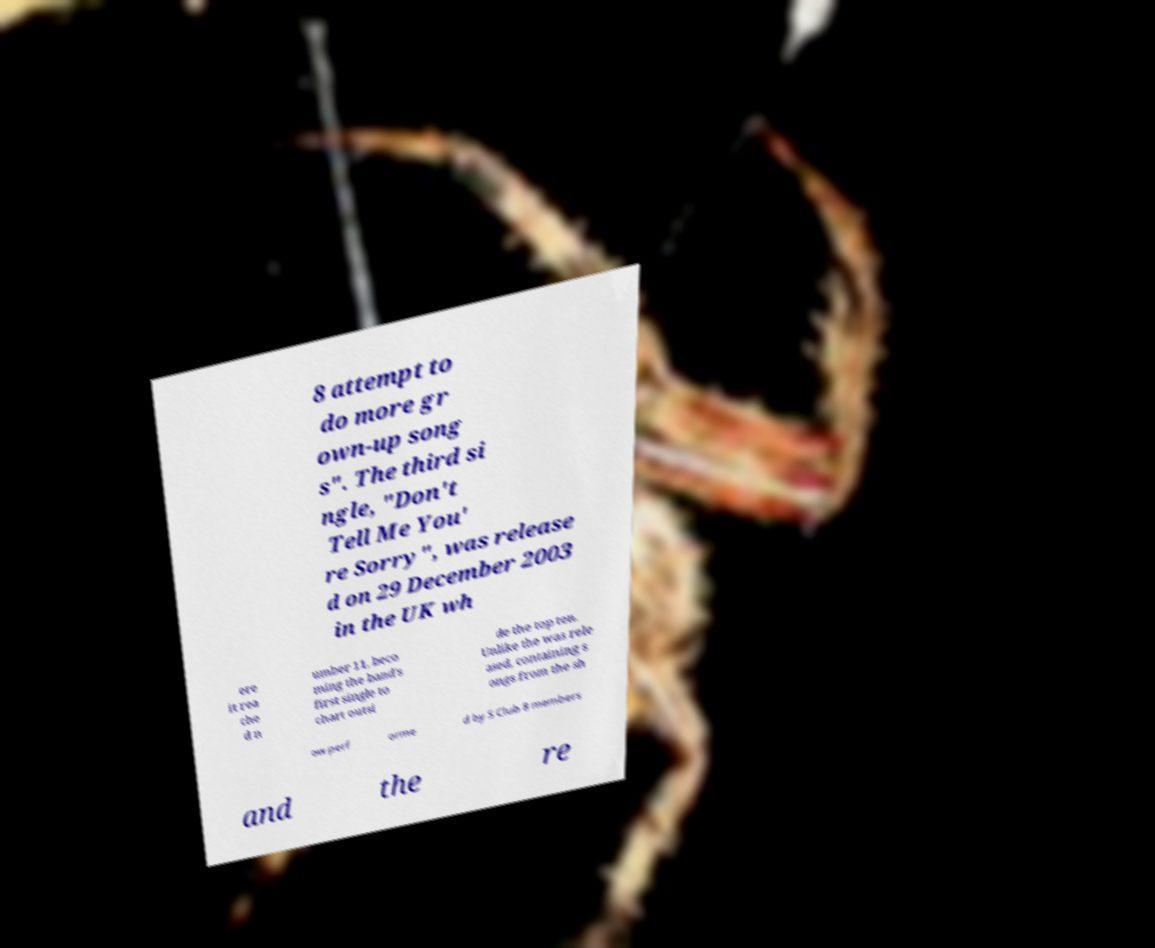Can you accurately transcribe the text from the provided image for me? 8 attempt to do more gr own-up song s". The third si ngle, "Don't Tell Me You' re Sorry", was release d on 29 December 2003 in the UK wh ere it rea che d n umber 11, beco ming the band's first single to chart outsi de the top ten. Unlike the was rele ased, containing s ongs from the sh ow perf orme d by S Club 8 members and the re 